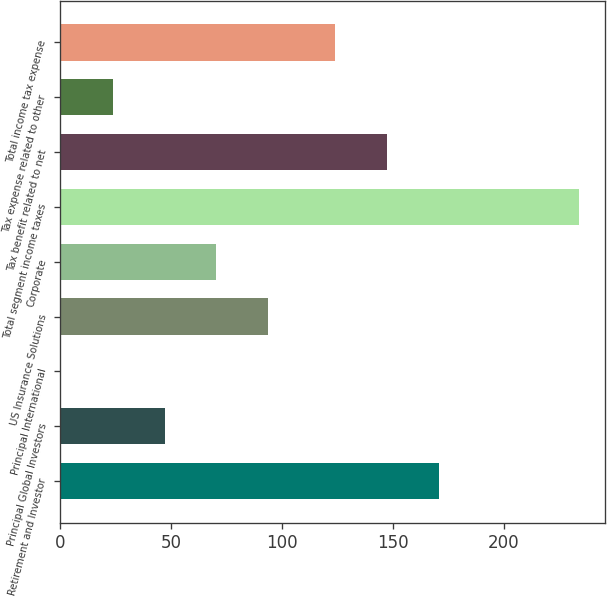Convert chart. <chart><loc_0><loc_0><loc_500><loc_500><bar_chart><fcel>Retirement and Investor<fcel>Principal Global Investors<fcel>Principal International<fcel>US Insurance Solutions<fcel>Corporate<fcel>Total segment income taxes<fcel>Tax benefit related to net<fcel>Tax expense related to other<fcel>Total income tax expense<nl><fcel>170.8<fcel>47.1<fcel>0.4<fcel>93.8<fcel>70.45<fcel>233.9<fcel>147.45<fcel>23.75<fcel>124.1<nl></chart> 